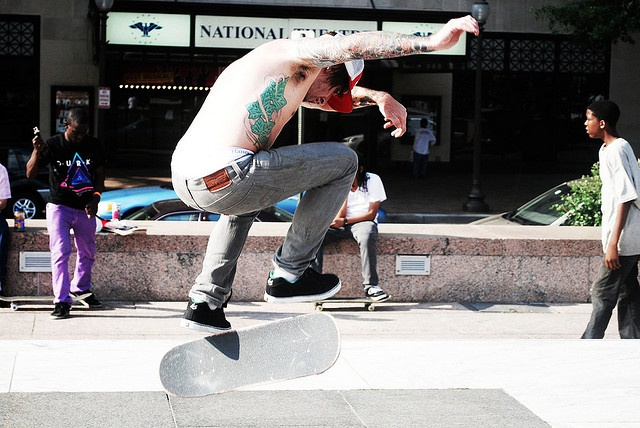Describe the objects in this image and their specific colors. I can see people in black, white, gray, and darkgray tones, skateboard in black, lightgray, and darkgray tones, people in black, white, darkgray, and gray tones, people in black, lavender, navy, and purple tones, and people in black, lightgray, gray, and darkgray tones in this image. 